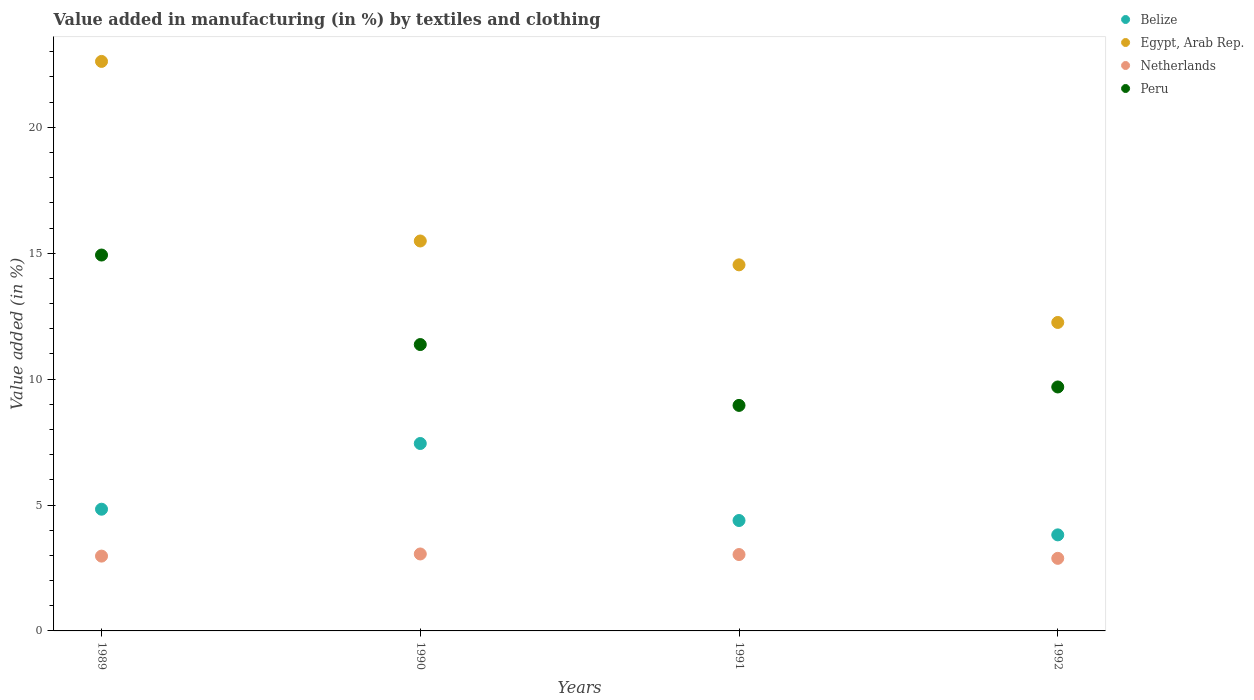What is the percentage of value added in manufacturing by textiles and clothing in Peru in 1991?
Your answer should be very brief. 8.96. Across all years, what is the maximum percentage of value added in manufacturing by textiles and clothing in Netherlands?
Make the answer very short. 3.06. Across all years, what is the minimum percentage of value added in manufacturing by textiles and clothing in Belize?
Give a very brief answer. 3.81. In which year was the percentage of value added in manufacturing by textiles and clothing in Egypt, Arab Rep. maximum?
Provide a short and direct response. 1989. What is the total percentage of value added in manufacturing by textiles and clothing in Peru in the graph?
Offer a terse response. 44.95. What is the difference between the percentage of value added in manufacturing by textiles and clothing in Peru in 1989 and that in 1991?
Provide a short and direct response. 5.97. What is the difference between the percentage of value added in manufacturing by textiles and clothing in Egypt, Arab Rep. in 1991 and the percentage of value added in manufacturing by textiles and clothing in Peru in 1989?
Your response must be concise. -0.39. What is the average percentage of value added in manufacturing by textiles and clothing in Peru per year?
Offer a terse response. 11.24. In the year 1990, what is the difference between the percentage of value added in manufacturing by textiles and clothing in Netherlands and percentage of value added in manufacturing by textiles and clothing in Belize?
Your answer should be very brief. -4.39. In how many years, is the percentage of value added in manufacturing by textiles and clothing in Egypt, Arab Rep. greater than 3 %?
Offer a terse response. 4. What is the ratio of the percentage of value added in manufacturing by textiles and clothing in Netherlands in 1989 to that in 1992?
Your answer should be very brief. 1.03. Is the percentage of value added in manufacturing by textiles and clothing in Peru in 1989 less than that in 1990?
Provide a succinct answer. No. Is the difference between the percentage of value added in manufacturing by textiles and clothing in Netherlands in 1989 and 1990 greater than the difference between the percentage of value added in manufacturing by textiles and clothing in Belize in 1989 and 1990?
Offer a terse response. Yes. What is the difference between the highest and the second highest percentage of value added in manufacturing by textiles and clothing in Belize?
Give a very brief answer. 2.61. What is the difference between the highest and the lowest percentage of value added in manufacturing by textiles and clothing in Peru?
Keep it short and to the point. 5.97. Does the percentage of value added in manufacturing by textiles and clothing in Peru monotonically increase over the years?
Your answer should be compact. No. Is the percentage of value added in manufacturing by textiles and clothing in Belize strictly greater than the percentage of value added in manufacturing by textiles and clothing in Netherlands over the years?
Offer a very short reply. Yes. Is the percentage of value added in manufacturing by textiles and clothing in Egypt, Arab Rep. strictly less than the percentage of value added in manufacturing by textiles and clothing in Peru over the years?
Give a very brief answer. No. What is the difference between two consecutive major ticks on the Y-axis?
Give a very brief answer. 5. Are the values on the major ticks of Y-axis written in scientific E-notation?
Your response must be concise. No. Does the graph contain grids?
Keep it short and to the point. No. How many legend labels are there?
Provide a short and direct response. 4. What is the title of the graph?
Provide a short and direct response. Value added in manufacturing (in %) by textiles and clothing. Does "Barbados" appear as one of the legend labels in the graph?
Give a very brief answer. No. What is the label or title of the Y-axis?
Offer a terse response. Value added (in %). What is the Value added (in %) of Belize in 1989?
Your answer should be very brief. 4.83. What is the Value added (in %) in Egypt, Arab Rep. in 1989?
Offer a very short reply. 22.62. What is the Value added (in %) in Netherlands in 1989?
Offer a terse response. 2.97. What is the Value added (in %) of Peru in 1989?
Provide a short and direct response. 14.93. What is the Value added (in %) of Belize in 1990?
Provide a short and direct response. 7.44. What is the Value added (in %) in Egypt, Arab Rep. in 1990?
Keep it short and to the point. 15.49. What is the Value added (in %) in Netherlands in 1990?
Your answer should be compact. 3.06. What is the Value added (in %) of Peru in 1990?
Keep it short and to the point. 11.37. What is the Value added (in %) in Belize in 1991?
Your response must be concise. 4.39. What is the Value added (in %) in Egypt, Arab Rep. in 1991?
Keep it short and to the point. 14.54. What is the Value added (in %) in Netherlands in 1991?
Your answer should be very brief. 3.03. What is the Value added (in %) of Peru in 1991?
Your response must be concise. 8.96. What is the Value added (in %) in Belize in 1992?
Make the answer very short. 3.81. What is the Value added (in %) of Egypt, Arab Rep. in 1992?
Make the answer very short. 12.25. What is the Value added (in %) in Netherlands in 1992?
Provide a short and direct response. 2.88. What is the Value added (in %) of Peru in 1992?
Your answer should be very brief. 9.69. Across all years, what is the maximum Value added (in %) in Belize?
Keep it short and to the point. 7.44. Across all years, what is the maximum Value added (in %) in Egypt, Arab Rep.?
Provide a succinct answer. 22.62. Across all years, what is the maximum Value added (in %) of Netherlands?
Keep it short and to the point. 3.06. Across all years, what is the maximum Value added (in %) in Peru?
Ensure brevity in your answer.  14.93. Across all years, what is the minimum Value added (in %) of Belize?
Offer a very short reply. 3.81. Across all years, what is the minimum Value added (in %) of Egypt, Arab Rep.?
Your response must be concise. 12.25. Across all years, what is the minimum Value added (in %) of Netherlands?
Keep it short and to the point. 2.88. Across all years, what is the minimum Value added (in %) in Peru?
Your answer should be very brief. 8.96. What is the total Value added (in %) in Belize in the graph?
Provide a short and direct response. 20.48. What is the total Value added (in %) of Egypt, Arab Rep. in the graph?
Offer a terse response. 64.89. What is the total Value added (in %) of Netherlands in the graph?
Provide a short and direct response. 11.94. What is the total Value added (in %) of Peru in the graph?
Make the answer very short. 44.95. What is the difference between the Value added (in %) in Belize in 1989 and that in 1990?
Your answer should be compact. -2.61. What is the difference between the Value added (in %) of Egypt, Arab Rep. in 1989 and that in 1990?
Make the answer very short. 7.13. What is the difference between the Value added (in %) of Netherlands in 1989 and that in 1990?
Provide a succinct answer. -0.09. What is the difference between the Value added (in %) of Peru in 1989 and that in 1990?
Your answer should be compact. 3.55. What is the difference between the Value added (in %) of Belize in 1989 and that in 1991?
Provide a short and direct response. 0.45. What is the difference between the Value added (in %) in Egypt, Arab Rep. in 1989 and that in 1991?
Give a very brief answer. 8.08. What is the difference between the Value added (in %) of Netherlands in 1989 and that in 1991?
Make the answer very short. -0.06. What is the difference between the Value added (in %) in Peru in 1989 and that in 1991?
Your answer should be very brief. 5.97. What is the difference between the Value added (in %) in Belize in 1989 and that in 1992?
Keep it short and to the point. 1.02. What is the difference between the Value added (in %) in Egypt, Arab Rep. in 1989 and that in 1992?
Ensure brevity in your answer.  10.37. What is the difference between the Value added (in %) of Netherlands in 1989 and that in 1992?
Provide a succinct answer. 0.09. What is the difference between the Value added (in %) in Peru in 1989 and that in 1992?
Provide a short and direct response. 5.24. What is the difference between the Value added (in %) of Belize in 1990 and that in 1991?
Provide a succinct answer. 3.06. What is the difference between the Value added (in %) in Egypt, Arab Rep. in 1990 and that in 1991?
Provide a succinct answer. 0.95. What is the difference between the Value added (in %) of Netherlands in 1990 and that in 1991?
Your answer should be very brief. 0.02. What is the difference between the Value added (in %) in Peru in 1990 and that in 1991?
Your answer should be very brief. 2.42. What is the difference between the Value added (in %) of Belize in 1990 and that in 1992?
Give a very brief answer. 3.63. What is the difference between the Value added (in %) of Egypt, Arab Rep. in 1990 and that in 1992?
Offer a very short reply. 3.24. What is the difference between the Value added (in %) of Netherlands in 1990 and that in 1992?
Offer a terse response. 0.17. What is the difference between the Value added (in %) in Peru in 1990 and that in 1992?
Your answer should be compact. 1.68. What is the difference between the Value added (in %) of Belize in 1991 and that in 1992?
Keep it short and to the point. 0.57. What is the difference between the Value added (in %) in Egypt, Arab Rep. in 1991 and that in 1992?
Offer a very short reply. 2.29. What is the difference between the Value added (in %) in Netherlands in 1991 and that in 1992?
Your answer should be compact. 0.15. What is the difference between the Value added (in %) of Peru in 1991 and that in 1992?
Provide a short and direct response. -0.73. What is the difference between the Value added (in %) of Belize in 1989 and the Value added (in %) of Egypt, Arab Rep. in 1990?
Your answer should be very brief. -10.65. What is the difference between the Value added (in %) in Belize in 1989 and the Value added (in %) in Netherlands in 1990?
Provide a short and direct response. 1.78. What is the difference between the Value added (in %) in Belize in 1989 and the Value added (in %) in Peru in 1990?
Your answer should be very brief. -6.54. What is the difference between the Value added (in %) of Egypt, Arab Rep. in 1989 and the Value added (in %) of Netherlands in 1990?
Provide a short and direct response. 19.56. What is the difference between the Value added (in %) of Egypt, Arab Rep. in 1989 and the Value added (in %) of Peru in 1990?
Offer a very short reply. 11.24. What is the difference between the Value added (in %) in Netherlands in 1989 and the Value added (in %) in Peru in 1990?
Offer a terse response. -8.4. What is the difference between the Value added (in %) in Belize in 1989 and the Value added (in %) in Egypt, Arab Rep. in 1991?
Provide a short and direct response. -9.7. What is the difference between the Value added (in %) in Belize in 1989 and the Value added (in %) in Netherlands in 1991?
Offer a very short reply. 1.8. What is the difference between the Value added (in %) in Belize in 1989 and the Value added (in %) in Peru in 1991?
Your answer should be very brief. -4.12. What is the difference between the Value added (in %) of Egypt, Arab Rep. in 1989 and the Value added (in %) of Netherlands in 1991?
Provide a short and direct response. 19.58. What is the difference between the Value added (in %) in Egypt, Arab Rep. in 1989 and the Value added (in %) in Peru in 1991?
Your answer should be compact. 13.66. What is the difference between the Value added (in %) in Netherlands in 1989 and the Value added (in %) in Peru in 1991?
Offer a very short reply. -5.99. What is the difference between the Value added (in %) in Belize in 1989 and the Value added (in %) in Egypt, Arab Rep. in 1992?
Make the answer very short. -7.42. What is the difference between the Value added (in %) of Belize in 1989 and the Value added (in %) of Netherlands in 1992?
Provide a short and direct response. 1.95. What is the difference between the Value added (in %) of Belize in 1989 and the Value added (in %) of Peru in 1992?
Make the answer very short. -4.85. What is the difference between the Value added (in %) of Egypt, Arab Rep. in 1989 and the Value added (in %) of Netherlands in 1992?
Provide a short and direct response. 19.74. What is the difference between the Value added (in %) of Egypt, Arab Rep. in 1989 and the Value added (in %) of Peru in 1992?
Your response must be concise. 12.93. What is the difference between the Value added (in %) of Netherlands in 1989 and the Value added (in %) of Peru in 1992?
Your response must be concise. -6.72. What is the difference between the Value added (in %) in Belize in 1990 and the Value added (in %) in Egypt, Arab Rep. in 1991?
Your answer should be compact. -7.1. What is the difference between the Value added (in %) in Belize in 1990 and the Value added (in %) in Netherlands in 1991?
Your answer should be very brief. 4.41. What is the difference between the Value added (in %) in Belize in 1990 and the Value added (in %) in Peru in 1991?
Offer a terse response. -1.51. What is the difference between the Value added (in %) in Egypt, Arab Rep. in 1990 and the Value added (in %) in Netherlands in 1991?
Your answer should be very brief. 12.45. What is the difference between the Value added (in %) in Egypt, Arab Rep. in 1990 and the Value added (in %) in Peru in 1991?
Provide a succinct answer. 6.53. What is the difference between the Value added (in %) in Netherlands in 1990 and the Value added (in %) in Peru in 1991?
Give a very brief answer. -5.9. What is the difference between the Value added (in %) of Belize in 1990 and the Value added (in %) of Egypt, Arab Rep. in 1992?
Keep it short and to the point. -4.81. What is the difference between the Value added (in %) in Belize in 1990 and the Value added (in %) in Netherlands in 1992?
Provide a succinct answer. 4.56. What is the difference between the Value added (in %) in Belize in 1990 and the Value added (in %) in Peru in 1992?
Offer a terse response. -2.25. What is the difference between the Value added (in %) of Egypt, Arab Rep. in 1990 and the Value added (in %) of Netherlands in 1992?
Ensure brevity in your answer.  12.6. What is the difference between the Value added (in %) in Egypt, Arab Rep. in 1990 and the Value added (in %) in Peru in 1992?
Give a very brief answer. 5.8. What is the difference between the Value added (in %) in Netherlands in 1990 and the Value added (in %) in Peru in 1992?
Make the answer very short. -6.63. What is the difference between the Value added (in %) in Belize in 1991 and the Value added (in %) in Egypt, Arab Rep. in 1992?
Give a very brief answer. -7.87. What is the difference between the Value added (in %) in Belize in 1991 and the Value added (in %) in Netherlands in 1992?
Your answer should be compact. 1.5. What is the difference between the Value added (in %) of Belize in 1991 and the Value added (in %) of Peru in 1992?
Your response must be concise. -5.3. What is the difference between the Value added (in %) of Egypt, Arab Rep. in 1991 and the Value added (in %) of Netherlands in 1992?
Your answer should be very brief. 11.66. What is the difference between the Value added (in %) of Egypt, Arab Rep. in 1991 and the Value added (in %) of Peru in 1992?
Your response must be concise. 4.85. What is the difference between the Value added (in %) in Netherlands in 1991 and the Value added (in %) in Peru in 1992?
Provide a succinct answer. -6.66. What is the average Value added (in %) of Belize per year?
Keep it short and to the point. 5.12. What is the average Value added (in %) in Egypt, Arab Rep. per year?
Your answer should be compact. 16.22. What is the average Value added (in %) of Netherlands per year?
Ensure brevity in your answer.  2.99. What is the average Value added (in %) in Peru per year?
Your answer should be very brief. 11.24. In the year 1989, what is the difference between the Value added (in %) in Belize and Value added (in %) in Egypt, Arab Rep.?
Your answer should be very brief. -17.78. In the year 1989, what is the difference between the Value added (in %) in Belize and Value added (in %) in Netherlands?
Ensure brevity in your answer.  1.86. In the year 1989, what is the difference between the Value added (in %) in Belize and Value added (in %) in Peru?
Offer a terse response. -10.09. In the year 1989, what is the difference between the Value added (in %) in Egypt, Arab Rep. and Value added (in %) in Netherlands?
Make the answer very short. 19.65. In the year 1989, what is the difference between the Value added (in %) of Egypt, Arab Rep. and Value added (in %) of Peru?
Provide a succinct answer. 7.69. In the year 1989, what is the difference between the Value added (in %) in Netherlands and Value added (in %) in Peru?
Provide a succinct answer. -11.96. In the year 1990, what is the difference between the Value added (in %) of Belize and Value added (in %) of Egypt, Arab Rep.?
Provide a succinct answer. -8.04. In the year 1990, what is the difference between the Value added (in %) in Belize and Value added (in %) in Netherlands?
Offer a terse response. 4.39. In the year 1990, what is the difference between the Value added (in %) of Belize and Value added (in %) of Peru?
Ensure brevity in your answer.  -3.93. In the year 1990, what is the difference between the Value added (in %) in Egypt, Arab Rep. and Value added (in %) in Netherlands?
Offer a very short reply. 12.43. In the year 1990, what is the difference between the Value added (in %) of Egypt, Arab Rep. and Value added (in %) of Peru?
Provide a succinct answer. 4.11. In the year 1990, what is the difference between the Value added (in %) in Netherlands and Value added (in %) in Peru?
Provide a short and direct response. -8.32. In the year 1991, what is the difference between the Value added (in %) in Belize and Value added (in %) in Egypt, Arab Rep.?
Your response must be concise. -10.15. In the year 1991, what is the difference between the Value added (in %) in Belize and Value added (in %) in Netherlands?
Offer a terse response. 1.35. In the year 1991, what is the difference between the Value added (in %) in Belize and Value added (in %) in Peru?
Provide a succinct answer. -4.57. In the year 1991, what is the difference between the Value added (in %) in Egypt, Arab Rep. and Value added (in %) in Netherlands?
Keep it short and to the point. 11.51. In the year 1991, what is the difference between the Value added (in %) in Egypt, Arab Rep. and Value added (in %) in Peru?
Make the answer very short. 5.58. In the year 1991, what is the difference between the Value added (in %) of Netherlands and Value added (in %) of Peru?
Provide a short and direct response. -5.92. In the year 1992, what is the difference between the Value added (in %) in Belize and Value added (in %) in Egypt, Arab Rep.?
Keep it short and to the point. -8.44. In the year 1992, what is the difference between the Value added (in %) of Belize and Value added (in %) of Netherlands?
Ensure brevity in your answer.  0.93. In the year 1992, what is the difference between the Value added (in %) of Belize and Value added (in %) of Peru?
Offer a very short reply. -5.87. In the year 1992, what is the difference between the Value added (in %) in Egypt, Arab Rep. and Value added (in %) in Netherlands?
Make the answer very short. 9.37. In the year 1992, what is the difference between the Value added (in %) of Egypt, Arab Rep. and Value added (in %) of Peru?
Keep it short and to the point. 2.56. In the year 1992, what is the difference between the Value added (in %) in Netherlands and Value added (in %) in Peru?
Offer a terse response. -6.81. What is the ratio of the Value added (in %) in Belize in 1989 to that in 1990?
Provide a succinct answer. 0.65. What is the ratio of the Value added (in %) in Egypt, Arab Rep. in 1989 to that in 1990?
Offer a terse response. 1.46. What is the ratio of the Value added (in %) of Netherlands in 1989 to that in 1990?
Keep it short and to the point. 0.97. What is the ratio of the Value added (in %) of Peru in 1989 to that in 1990?
Your response must be concise. 1.31. What is the ratio of the Value added (in %) in Belize in 1989 to that in 1991?
Ensure brevity in your answer.  1.1. What is the ratio of the Value added (in %) of Egypt, Arab Rep. in 1989 to that in 1991?
Your response must be concise. 1.56. What is the ratio of the Value added (in %) of Netherlands in 1989 to that in 1991?
Give a very brief answer. 0.98. What is the ratio of the Value added (in %) of Peru in 1989 to that in 1991?
Your answer should be compact. 1.67. What is the ratio of the Value added (in %) in Belize in 1989 to that in 1992?
Your response must be concise. 1.27. What is the ratio of the Value added (in %) of Egypt, Arab Rep. in 1989 to that in 1992?
Offer a terse response. 1.85. What is the ratio of the Value added (in %) in Netherlands in 1989 to that in 1992?
Provide a short and direct response. 1.03. What is the ratio of the Value added (in %) of Peru in 1989 to that in 1992?
Provide a succinct answer. 1.54. What is the ratio of the Value added (in %) in Belize in 1990 to that in 1991?
Give a very brief answer. 1.7. What is the ratio of the Value added (in %) in Egypt, Arab Rep. in 1990 to that in 1991?
Give a very brief answer. 1.07. What is the ratio of the Value added (in %) of Netherlands in 1990 to that in 1991?
Your answer should be compact. 1.01. What is the ratio of the Value added (in %) of Peru in 1990 to that in 1991?
Offer a terse response. 1.27. What is the ratio of the Value added (in %) in Belize in 1990 to that in 1992?
Your answer should be very brief. 1.95. What is the ratio of the Value added (in %) of Egypt, Arab Rep. in 1990 to that in 1992?
Give a very brief answer. 1.26. What is the ratio of the Value added (in %) of Netherlands in 1990 to that in 1992?
Offer a terse response. 1.06. What is the ratio of the Value added (in %) of Peru in 1990 to that in 1992?
Your answer should be very brief. 1.17. What is the ratio of the Value added (in %) in Belize in 1991 to that in 1992?
Your answer should be very brief. 1.15. What is the ratio of the Value added (in %) in Egypt, Arab Rep. in 1991 to that in 1992?
Your answer should be very brief. 1.19. What is the ratio of the Value added (in %) in Netherlands in 1991 to that in 1992?
Your answer should be compact. 1.05. What is the ratio of the Value added (in %) of Peru in 1991 to that in 1992?
Give a very brief answer. 0.92. What is the difference between the highest and the second highest Value added (in %) in Belize?
Offer a very short reply. 2.61. What is the difference between the highest and the second highest Value added (in %) of Egypt, Arab Rep.?
Offer a terse response. 7.13. What is the difference between the highest and the second highest Value added (in %) of Netherlands?
Provide a succinct answer. 0.02. What is the difference between the highest and the second highest Value added (in %) of Peru?
Ensure brevity in your answer.  3.55. What is the difference between the highest and the lowest Value added (in %) in Belize?
Your answer should be very brief. 3.63. What is the difference between the highest and the lowest Value added (in %) of Egypt, Arab Rep.?
Your answer should be very brief. 10.37. What is the difference between the highest and the lowest Value added (in %) of Netherlands?
Your answer should be compact. 0.17. What is the difference between the highest and the lowest Value added (in %) in Peru?
Ensure brevity in your answer.  5.97. 